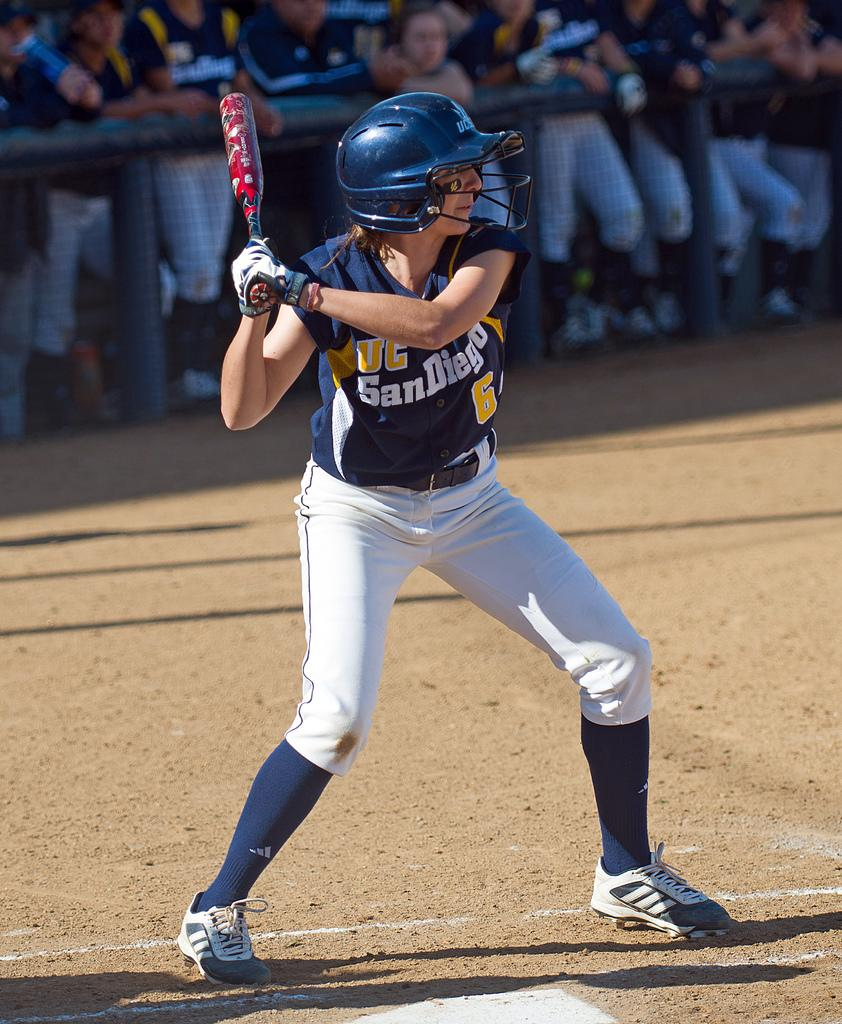What is the person in the image holding? The person is holding a bat in their hands. What protective gear is the person wearing? The person is wearing a helmet. What can be seen in the background of the image? There is a group of people in the background of the image. How are the group of people positioned in relation to the person with the bat? The group of people is standing behind a fence. What advice does the doll give to the person holding the bat in the image? There is no doll present in the image, so it is not possible to answer that question. 